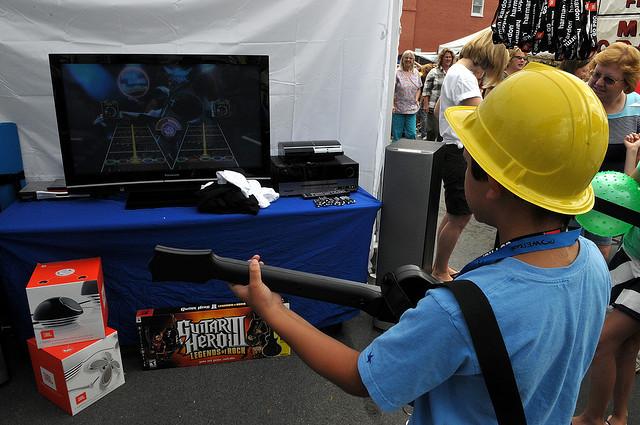What is the name of the game the boy is playing?
Give a very brief answer. Guitar hero. Is the boy playing the game at home?
Give a very brief answer. No. Are people standing around, off to the side?
Concise answer only. Yes. 